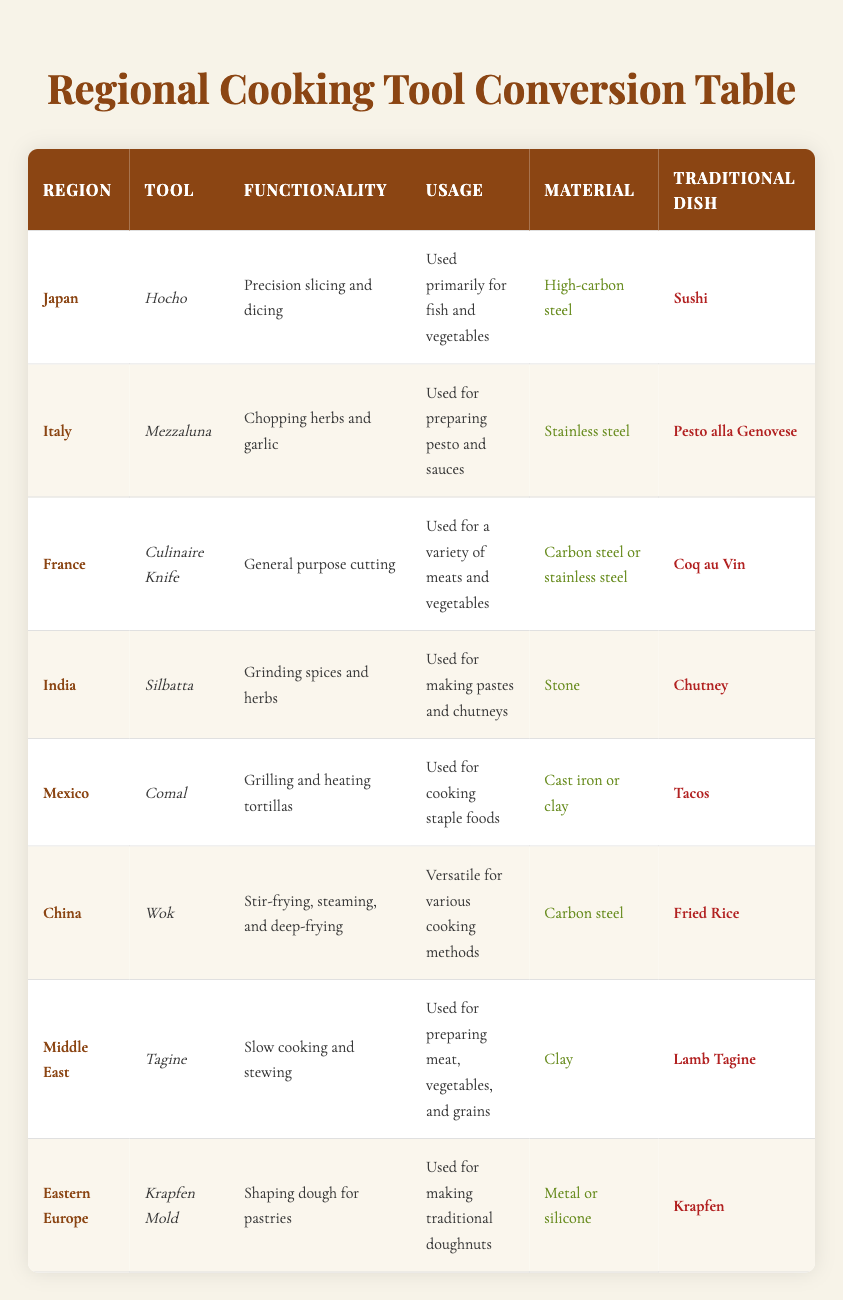What is the traditional dish associated with the Hocho? The traditional dish associated with the Hocho, which is used in Japan, is Sushi, as stated in the table.
Answer: Sushi Which tool is used for making traditional doughnuts in Eastern Europe? The Krapfen Mold is the tool used for making traditional doughnuts, as indicated in the Eastern Europe row of the table.
Answer: Krapfen Mold Does the Wok have a specific functionality listed in the table? Yes, the Wok is listed with the functionality of stir-frying, steaming, and deep-frying, as shown in the table's entry for China.
Answer: Yes How many cooking tools listed are made from steel? There are four cooking tools made from steel: Hocho (high-carbon steel), Mezzaluna (stainless steel), Culinaire Knife (carbon steel or stainless steel), and Wok (carbon steel). Thus, the count is four.
Answer: Four Is the material used for the Silbatta the same as the material used for the Comal? No, the Silbatta is made of stone, while the Comal is made of cast iron or clay. The materials are different, confirmed by looking at both entries in the table.
Answer: No Which cooking tool has the functionality of "slow cooking and stewing"? The Tagine is the cooking tool with the functionality of slow cooking and stewing, as evidenced in the Middle East row.
Answer: Tagine In terms of usage, which tool is specific to preparing pesto and sauces? The Mezzaluna is specifically used for preparing pesto and sauces, as noted in the entry for Italy in the table.
Answer: Mezzaluna What is the average number of cooking tools per region if the table lists 8 tools across 8 regions? The average is calculated by dividing the total tools (8) by the number of regions (8). Therefore, 8/8 = 1 tool per region is the average.
Answer: 1 What is the functionality of the Comal, and which traditional dish does it relate to? The Comal's functionality is grilling and heating tortillas, and it is related to the traditional dish of Tacos, as indicated in the table.
Answer: Grilling and heating tortillas; Tacos 